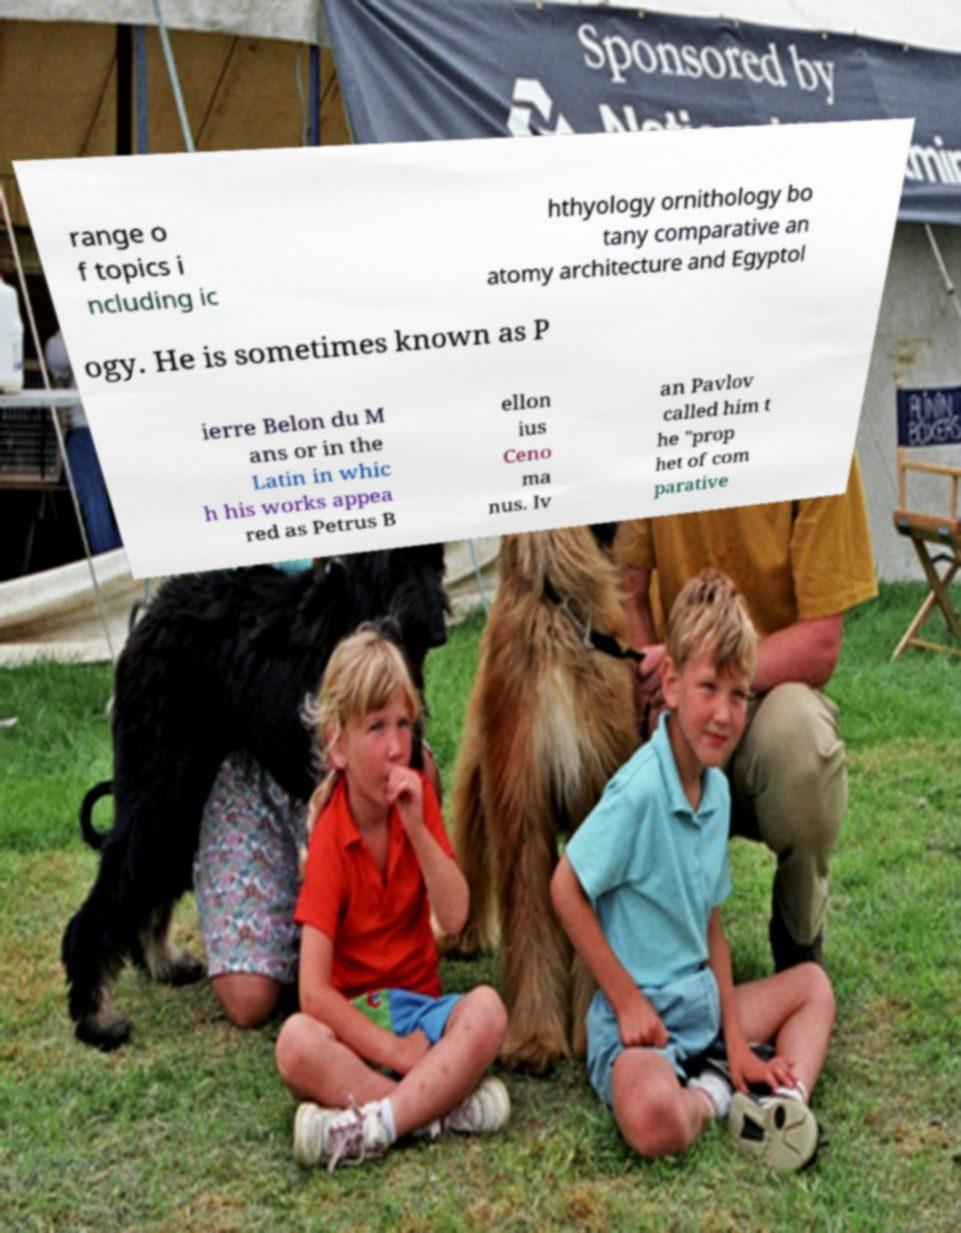Could you assist in decoding the text presented in this image and type it out clearly? range o f topics i ncluding ic hthyology ornithology bo tany comparative an atomy architecture and Egyptol ogy. He is sometimes known as P ierre Belon du M ans or in the Latin in whic h his works appea red as Petrus B ellon ius Ceno ma nus. Iv an Pavlov called him t he "prop het of com parative 